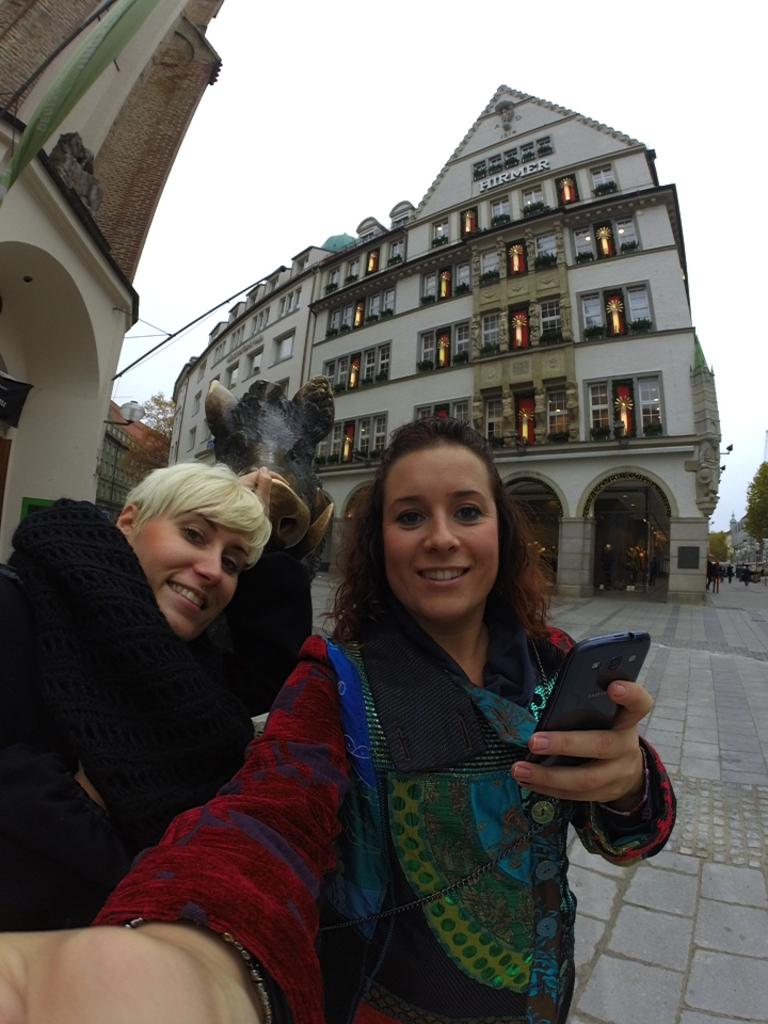How many ladies are in the image? There are two ladies in the image. What is one of the ladies holding? One of the ladies is holding a cell phone. What can be seen behind the ladies? There is a sculpture behind the ladies. What type of structures are visible in the image? There are buildings visible in the image. What is present in the image that might provide illumination? Lights are present in the image. What architectural feature can be seen in the buildings? Windows are visible in the image. What type of natural vegetation is present in the image? Trees are present in the image. What part of the natural environment is visible in the image? The sky is visible in the image. What type of kite is being flown by the army in the image? There is no kite or army present in the image. What type of apparel are the ladies wearing in the image? The provided facts do not mention the apparel worn by the ladies, so we cannot answer this question definitively. 